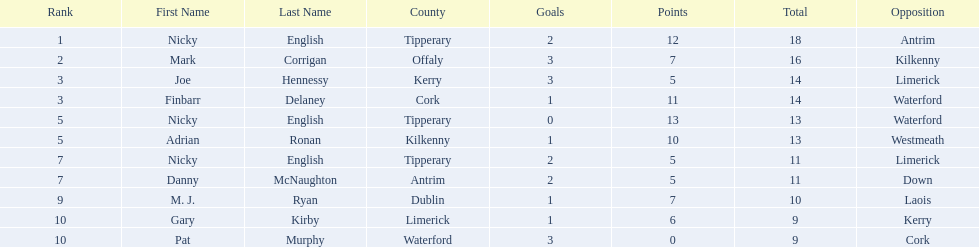Which of the following players were ranked in the bottom 5? Nicky English, Danny McNaughton, M. J. Ryan, Gary Kirby, Pat Murphy. Of these, whose tallies were not 2-5? M. J. Ryan, Gary Kirby, Pat Murphy. From the above three, which one scored more than 9 total points? M. J. Ryan. 